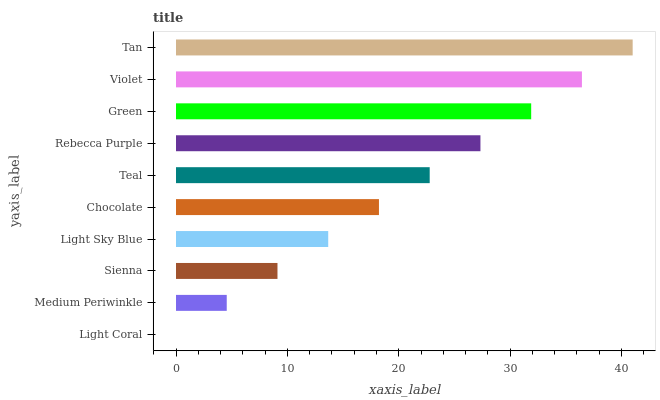Is Light Coral the minimum?
Answer yes or no. Yes. Is Tan the maximum?
Answer yes or no. Yes. Is Medium Periwinkle the minimum?
Answer yes or no. No. Is Medium Periwinkle the maximum?
Answer yes or no. No. Is Medium Periwinkle greater than Light Coral?
Answer yes or no. Yes. Is Light Coral less than Medium Periwinkle?
Answer yes or no. Yes. Is Light Coral greater than Medium Periwinkle?
Answer yes or no. No. Is Medium Periwinkle less than Light Coral?
Answer yes or no. No. Is Teal the high median?
Answer yes or no. Yes. Is Chocolate the low median?
Answer yes or no. Yes. Is Light Sky Blue the high median?
Answer yes or no. No. Is Medium Periwinkle the low median?
Answer yes or no. No. 